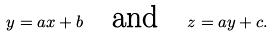<formula> <loc_0><loc_0><loc_500><loc_500>y = a x + b \quad \text {and} \quad z = a y + c .</formula> 